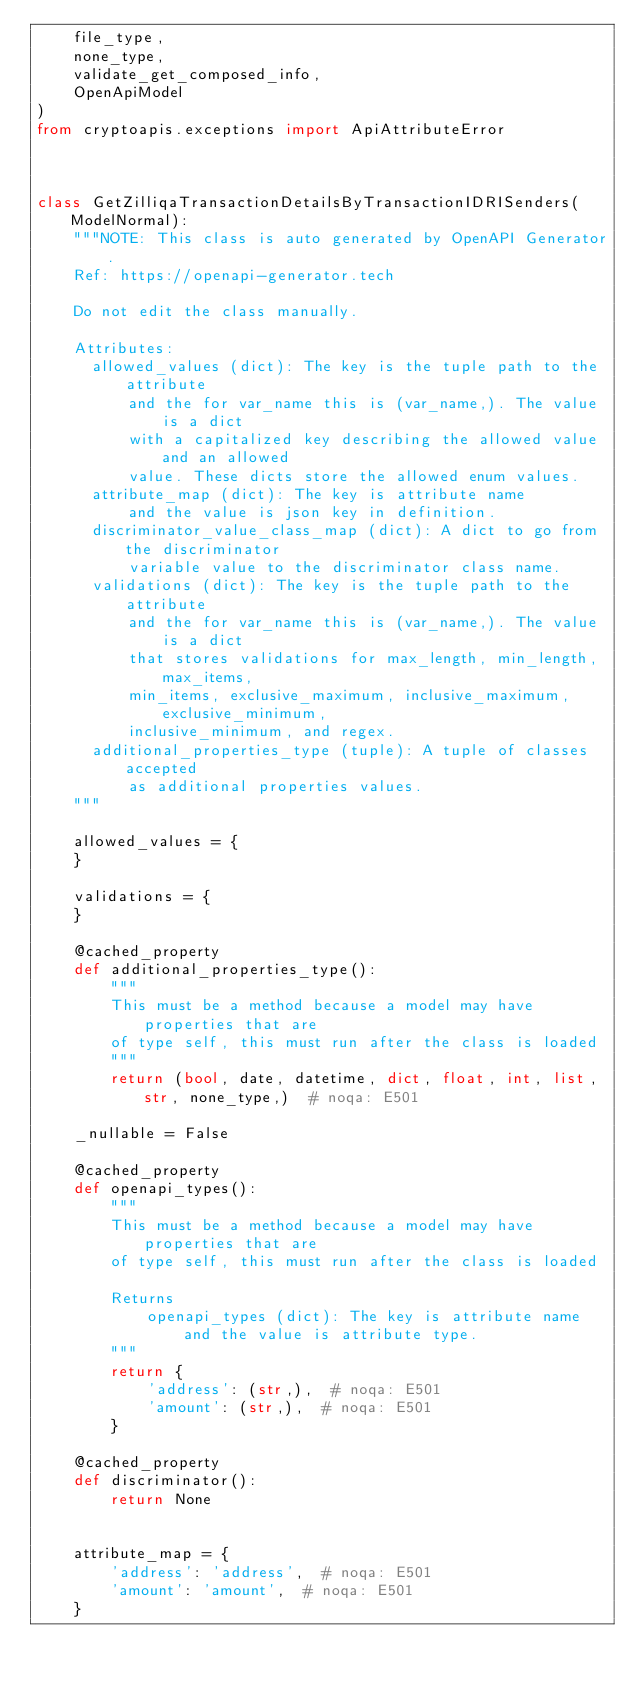Convert code to text. <code><loc_0><loc_0><loc_500><loc_500><_Python_>    file_type,
    none_type,
    validate_get_composed_info,
    OpenApiModel
)
from cryptoapis.exceptions import ApiAttributeError



class GetZilliqaTransactionDetailsByTransactionIDRISenders(ModelNormal):
    """NOTE: This class is auto generated by OpenAPI Generator.
    Ref: https://openapi-generator.tech

    Do not edit the class manually.

    Attributes:
      allowed_values (dict): The key is the tuple path to the attribute
          and the for var_name this is (var_name,). The value is a dict
          with a capitalized key describing the allowed value and an allowed
          value. These dicts store the allowed enum values.
      attribute_map (dict): The key is attribute name
          and the value is json key in definition.
      discriminator_value_class_map (dict): A dict to go from the discriminator
          variable value to the discriminator class name.
      validations (dict): The key is the tuple path to the attribute
          and the for var_name this is (var_name,). The value is a dict
          that stores validations for max_length, min_length, max_items,
          min_items, exclusive_maximum, inclusive_maximum, exclusive_minimum,
          inclusive_minimum, and regex.
      additional_properties_type (tuple): A tuple of classes accepted
          as additional properties values.
    """

    allowed_values = {
    }

    validations = {
    }

    @cached_property
    def additional_properties_type():
        """
        This must be a method because a model may have properties that are
        of type self, this must run after the class is loaded
        """
        return (bool, date, datetime, dict, float, int, list, str, none_type,)  # noqa: E501

    _nullable = False

    @cached_property
    def openapi_types():
        """
        This must be a method because a model may have properties that are
        of type self, this must run after the class is loaded

        Returns
            openapi_types (dict): The key is attribute name
                and the value is attribute type.
        """
        return {
            'address': (str,),  # noqa: E501
            'amount': (str,),  # noqa: E501
        }

    @cached_property
    def discriminator():
        return None


    attribute_map = {
        'address': 'address',  # noqa: E501
        'amount': 'amount',  # noqa: E501
    }
</code> 